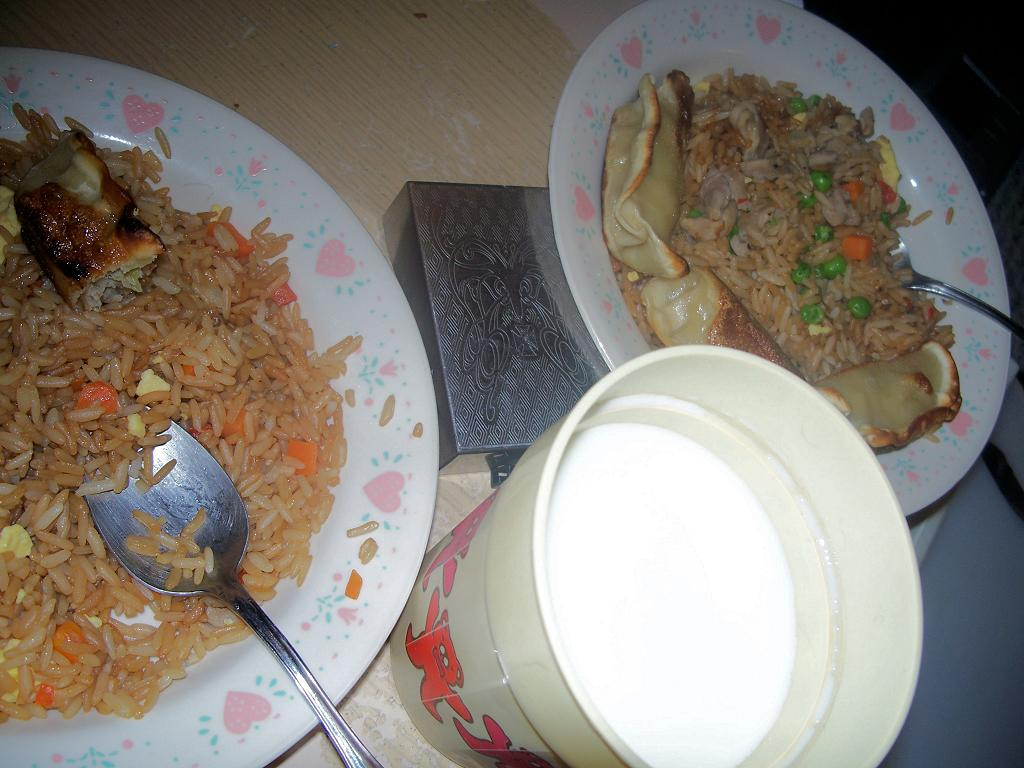What objects in the image are typically used for serving or eating food? There are plates and glasses visible in the image. What is the main subject of the image? The main subject of the image is food. What type of container is present in the image? There is a steel box in the image. What type of celery can be seen growing in the image? There is no celery present in the image. What type of marble is visible in the image? There is no marble present in the image. 